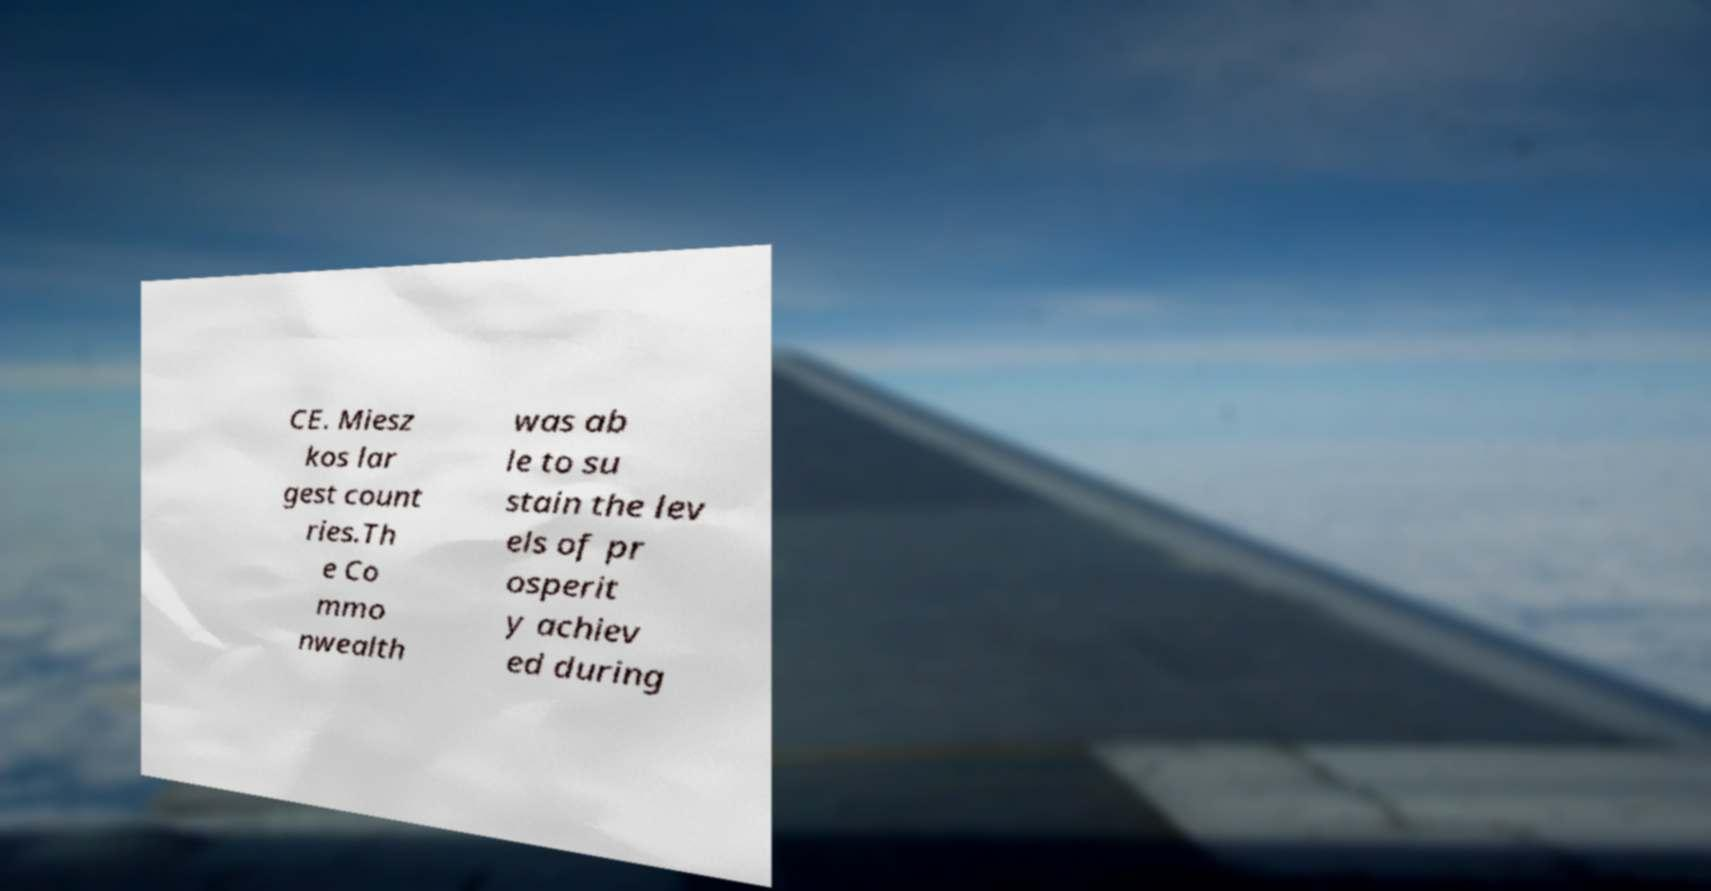What messages or text are displayed in this image? I need them in a readable, typed format. CE. Miesz kos lar gest count ries.Th e Co mmo nwealth was ab le to su stain the lev els of pr osperit y achiev ed during 